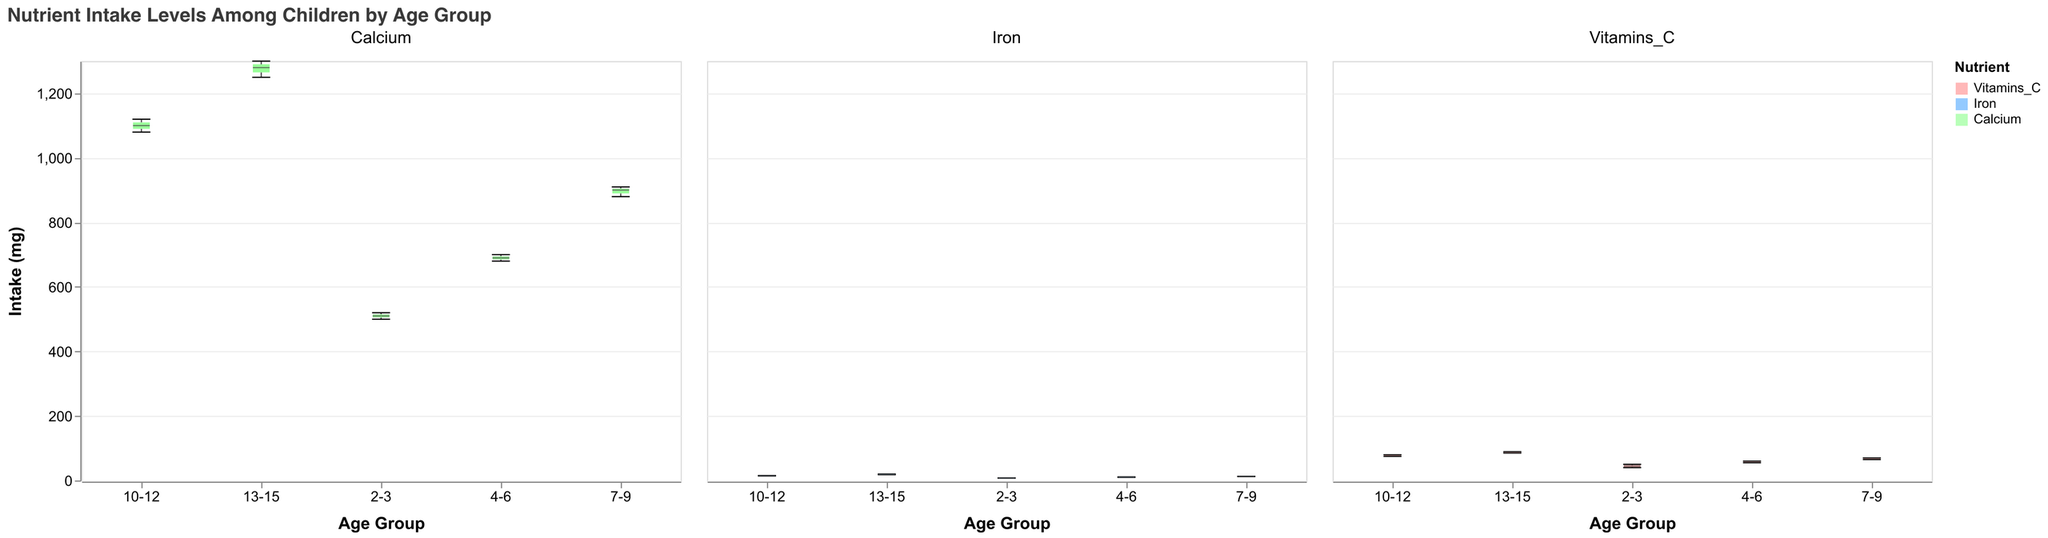what's the title of the figure? The title of a figure is typically shown at the top. For this figure, it reads, "Nutrient Intake Levels Among Children by Age Group".
Answer: Nutrient Intake Levels Among Children by Age Group Which age group has the highest median intake of Calcium? Observing the notched box plots for each age group in the Calcium section, the median values are denoted by a distinct line within each box. The highest median line is in the 13-15 age group.
Answer: 13-15 What is the range of Vitamin C intake for the 7-9 age group? The range is represented by the distance between the minimum and maximum data points shown by the whiskers in the 7-9 age group's box plot for Vitamins C. The minimum is 65 and the maximum is 70.
Answer: 65-70 How does the median iron intake for the 10-12 age group compare to the 13-15 age group? The median value is represented by the line in the middle of the box for each age group. In the Iron section, the 10-12 age group has a median of approximately 15 mg, whereas the 13-15 age group has a median of about 19 mg. Therefore, the 13-15 age group's median intake is higher.
Answer: 13-15 group has higher median What is the notch in the 2-3 age group's box plot for Vitamins C representing? The notches in the box plot represent the confidence interval around the median. For the 2-3 age group's box plot in the Vitamins C section, the notch provides an indication of the variability in the median value.
Answer: Confidence interval around the median Which nutrient shows the largest increase in median intake when comparing the 2-3 age group with the 13-15 age group? Comparing the medians in the box plots of all nutrients for both age groups, Calcium shows the most considerable increase in median intake from around 500 mg in the 2-3 group to around 1300 mg in the 13-15 group.
Answer: Calcium Which age group has the smallest range of intake values for Iron? The range is the distance between the lowest and highest data points. In the Iron section, the 2-3 age group displays the shortest whiskers, indicating the smallest range.
Answer: 2-3 